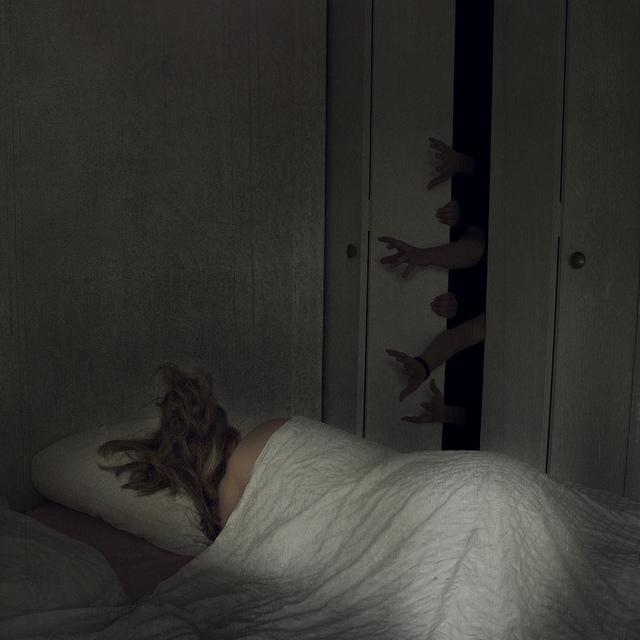What are coming out of the closet? Please explain your reasoning. hands. Hands and bits of arms extend from out of the closets shadows in this bit of trick photography. 